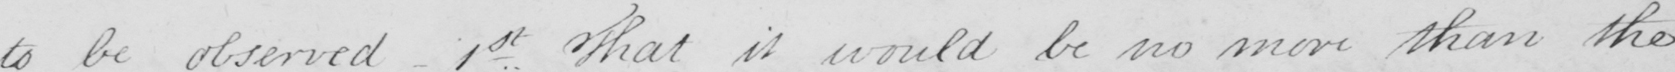What does this handwritten line say? to be observed - 1st That it would be no more than the 